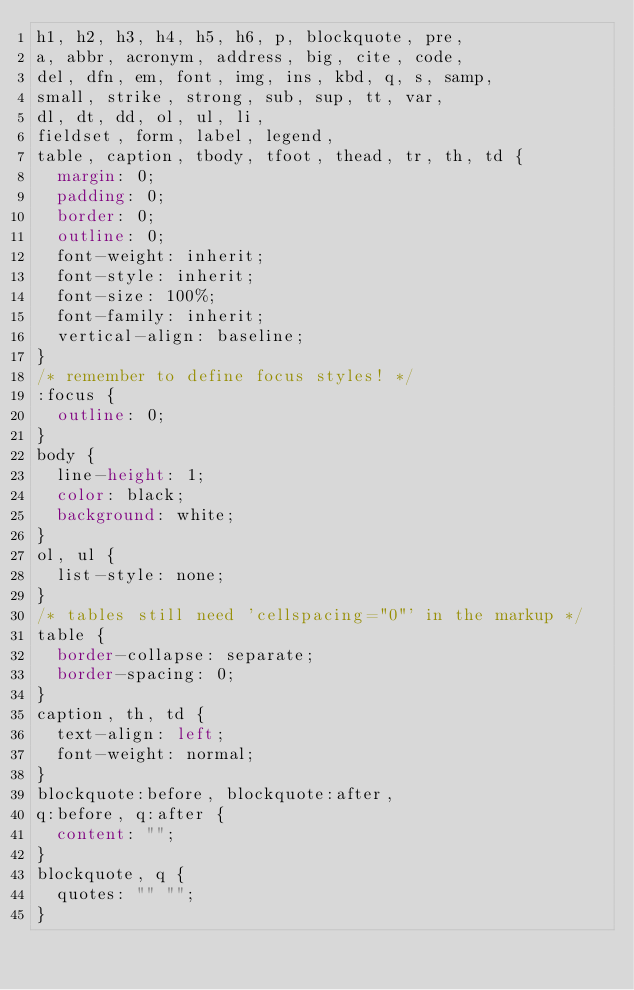Convert code to text. <code><loc_0><loc_0><loc_500><loc_500><_CSS_>h1, h2, h3, h4, h5, h6, p, blockquote, pre,
a, abbr, acronym, address, big, cite, code,
del, dfn, em, font, img, ins, kbd, q, s, samp,
small, strike, strong, sub, sup, tt, var,
dl, dt, dd, ol, ul, li,
fieldset, form, label, legend,
table, caption, tbody, tfoot, thead, tr, th, td {
	margin: 0;
	padding: 0;
	border: 0;
	outline: 0;
	font-weight: inherit;
	font-style: inherit;
	font-size: 100%;
	font-family: inherit;
	vertical-align: baseline;
}
/* remember to define focus styles! */
:focus {
	outline: 0;
}
body {
	line-height: 1;
	color: black;
	background: white;
}
ol, ul {
	list-style: none;
}
/* tables still need 'cellspacing="0"' in the markup */
table {
	border-collapse: separate;
	border-spacing: 0;
}
caption, th, td {
	text-align: left;
	font-weight: normal;
}
blockquote:before, blockquote:after,
q:before, q:after {
	content: "";
}
blockquote, q {
	quotes: "" "";
}
</code> 